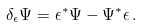<formula> <loc_0><loc_0><loc_500><loc_500>\delta _ { \epsilon } \Psi = \epsilon ^ { * } \Psi - \Psi ^ { * } \epsilon \, .</formula> 